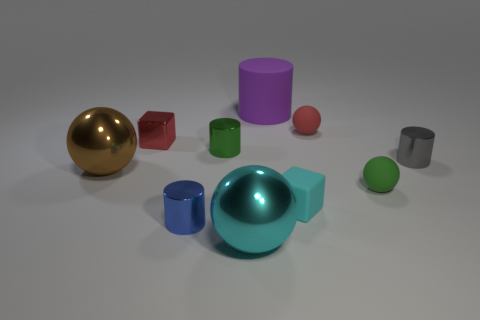Subtract all spheres. How many objects are left? 6 Add 9 purple matte cylinders. How many purple matte cylinders are left? 10 Add 7 small brown metal blocks. How many small brown metal blocks exist? 7 Subtract 0 red cylinders. How many objects are left? 10 Subtract all small green rubber cylinders. Subtract all small rubber cubes. How many objects are left? 9 